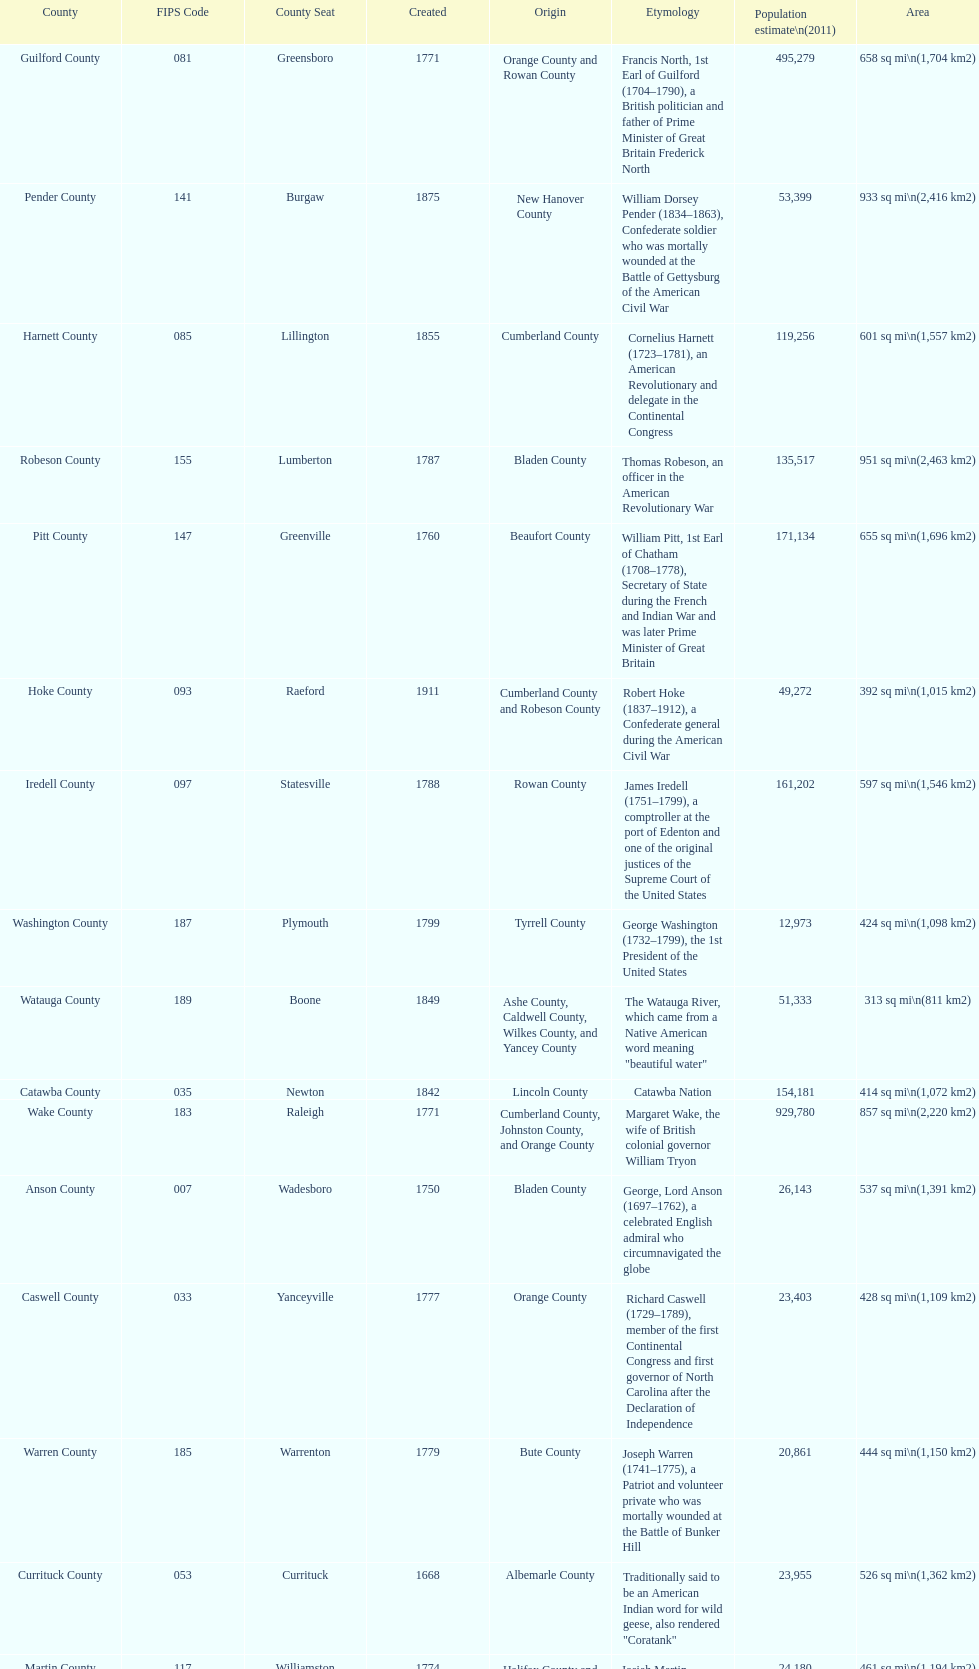Which county has a higher population, alamance or alexander? Alamance County. 